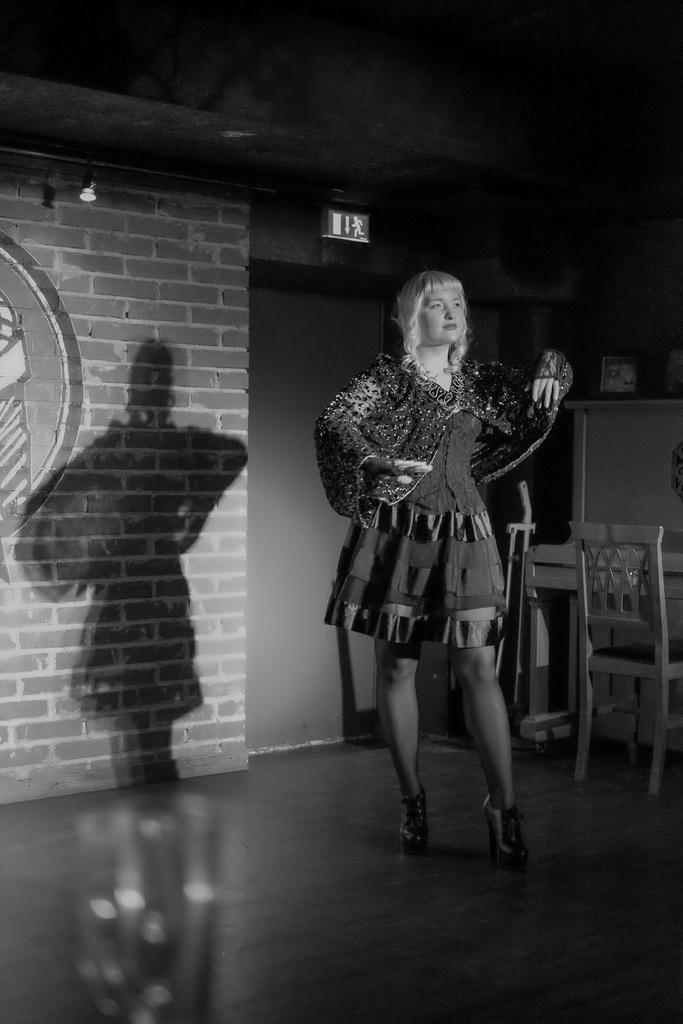Could you give a brief overview of what you see in this image? In this black and white picture there is a woman standing. Beside to her there is table with chair. Behind her there is wall. There are lights and a sign board to the ceiling. 